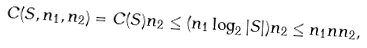Convert formula to latex. <formula><loc_0><loc_0><loc_500><loc_500>C ( S , n _ { 1 } , n _ { 2 } ) = C ( S ) n _ { 2 } \leq ( n _ { 1 } \log _ { 2 } | S | ) n _ { 2 } \leq n _ { 1 } n n _ { 2 } ,</formula> 